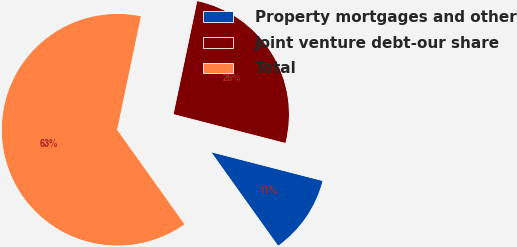<chart> <loc_0><loc_0><loc_500><loc_500><pie_chart><fcel>Property mortgages and other<fcel>Joint venture debt-our share<fcel>Total<nl><fcel>11.12%<fcel>25.73%<fcel>63.15%<nl></chart> 